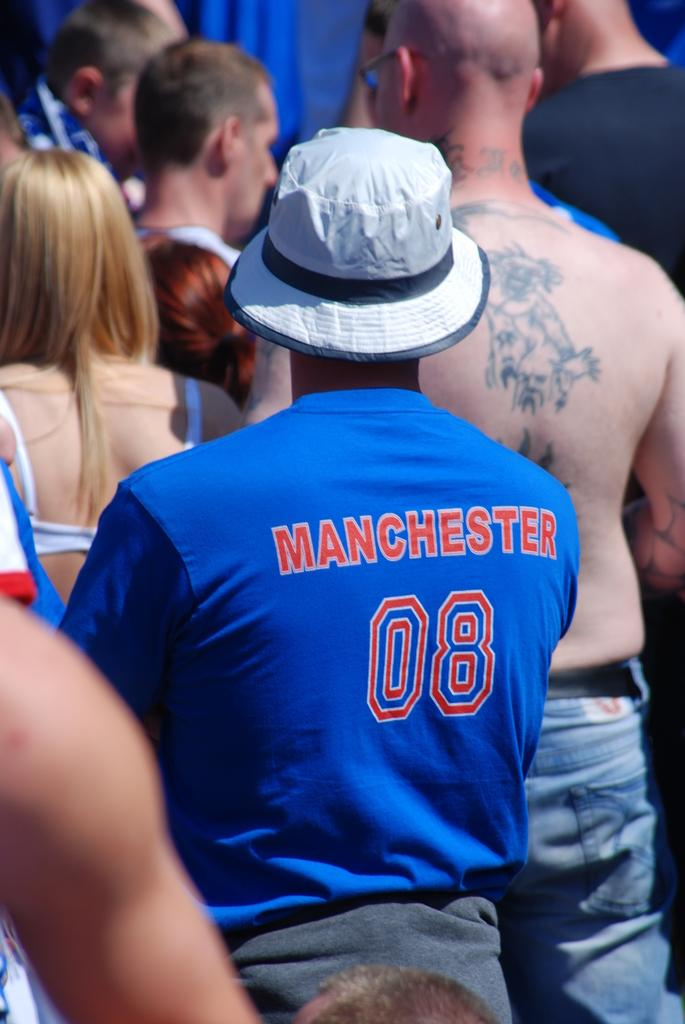<image>
Describe the image concisely. A person wearing a Manchester 08 jersey stands in a crowd. 